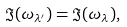<formula> <loc_0><loc_0><loc_500><loc_500>\Im { ( \omega _ { \lambda ^ { \prime } } ) } = \Im { ( \omega _ { \lambda } ) } ,</formula> 